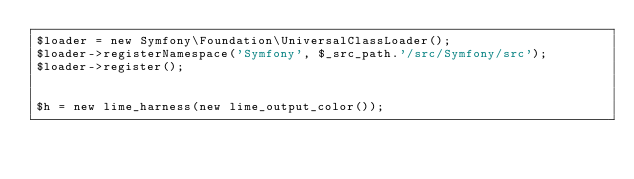Convert code to text. <code><loc_0><loc_0><loc_500><loc_500><_PHP_>$loader = new Symfony\Foundation\UniversalClassLoader();
$loader->registerNamespace('Symfony', $_src_path.'/src/Symfony/src');
$loader->register();


$h = new lime_harness(new lime_output_color());</code> 